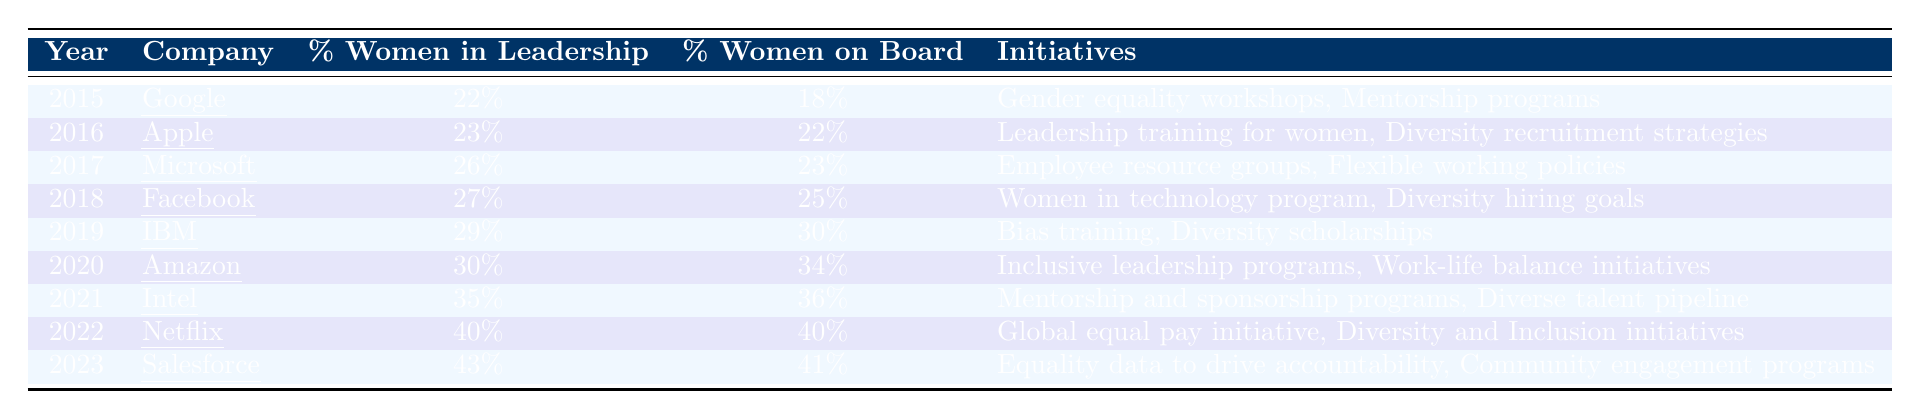What was the percentage of women in leadership at Google in 2015? The table indicates that in 2015, Google had 22% of women in leadership roles.
Answer: 22% Which company had the highest percentage of women on the board in 2019? According to the table, IBM had the highest percentage of women on the board in 2019, with 30%.
Answer: IBM What initiatives were implemented by Facebook in 2018? The table lists the initiatives for Facebook in 2018 as "Women in technology program" and "Diversity hiring goals."
Answer: Women in technology program, Diversity hiring goals By what percentage did women in leadership roles increase from Apple in 2016 to Salesforce in 2023? Apple had 23% women in leadership in 2016, while Salesforce had 43% in 2023. The difference is 43 - 23 = 20%.
Answer: 20% Did Netflix have a higher percentage of women in leadership than Amazon in 2020? The table shows that Netflix had 40% in 2022 and Amazon had 30% in 2020. Comparing these values, Netflix did have a higher percentage than Amazon when considering the years, but not in the same year.
Answer: No What was the average percentage of women in leadership roles from 2015 to 2023? The total percentage from each year (22 + 23 + 26 + 27 + 29 + 30 + 35 + 40 + 43 =  305) divided by the number of data points (9) gives an average of 305/9 ≈ 33.89%.
Answer: Approximately 33.89% Which company saw the greatest increase in women in leadership from 2015 to 2021? Comparing the values, Google had 22% in 2015, while Intel had 35% in 2021, resulting in an increase of 35 - 22 = 13%.
Answer: Intel True or False: Amazon had a higher percentage of women on the board than IBM in 2019. The table indicates that IBM had 30% and Amazon had 34% in their respective years. Therefore, the statement is false since IBM had a lower percentage.
Answer: False What was the change in initiatives from Microsoft in 2017 to Netflix in 2022? Microsoft in 2017 focused on "Employee resource groups" and "Flexible working policies," while Netflix in 2022 implemented "Global equal pay initiative" and "Diversity and Inclusion initiatives." This highlights a shift from internal support to broader equality efforts.
Answer: Shift to broader equality initiatives 